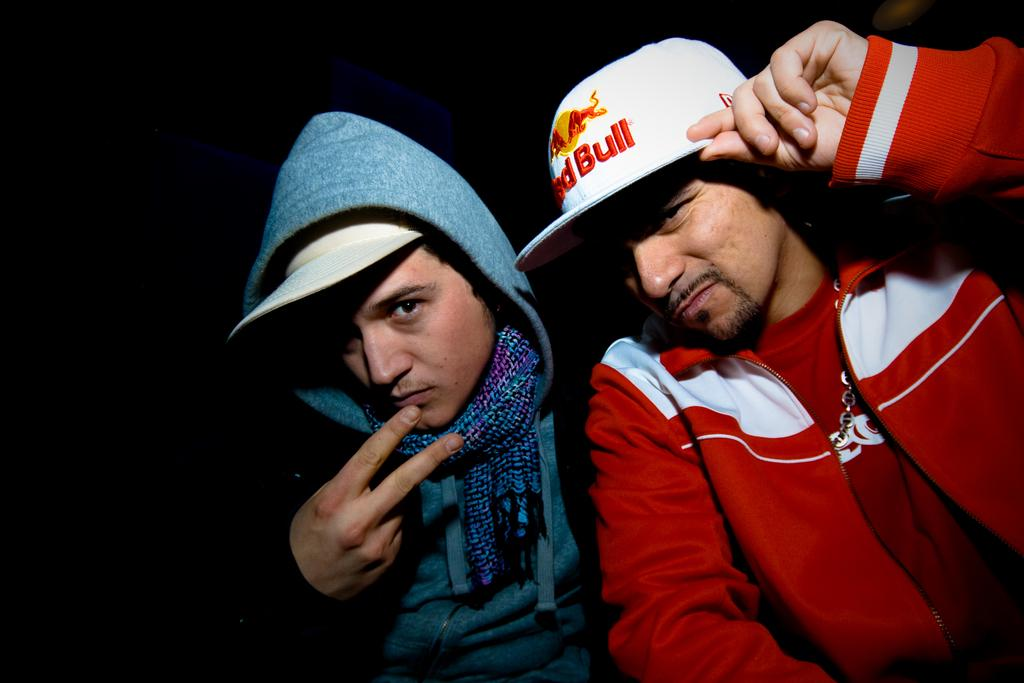<image>
Render a clear and concise summary of the photo. Two men in baseball caps, one that says Red Bull 